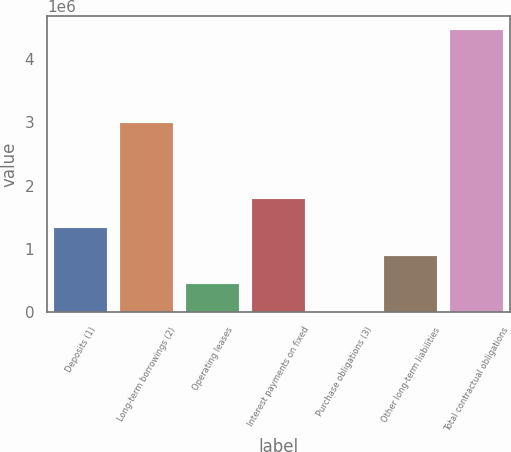Convert chart to OTSL. <chart><loc_0><loc_0><loc_500><loc_500><bar_chart><fcel>Deposits (1)<fcel>Long-term borrowings (2)<fcel>Operating leases<fcel>Interest payments on fixed<fcel>Purchase obligations (3)<fcel>Other long-term liabilities<fcel>Total contractual obligations<nl><fcel>1.33861e+06<fcel>2.9864e+06<fcel>449112<fcel>1.78336e+06<fcel>4364<fcel>893860<fcel>4.45184e+06<nl></chart> 